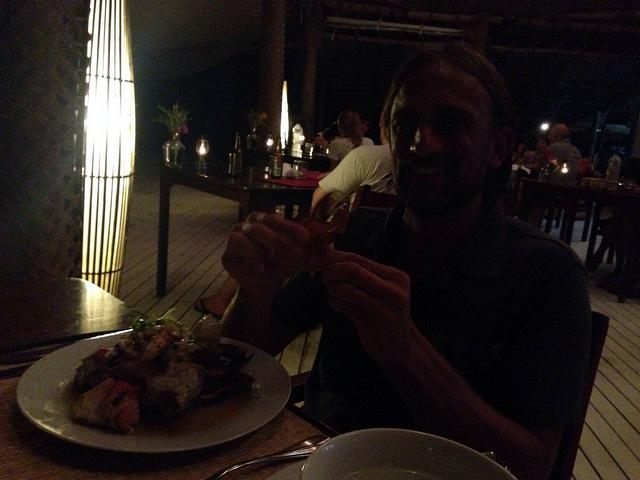What kind of food is the man consuming?

Choices:
A) steak
B) seafood
C) pork
D) lamb seafood 